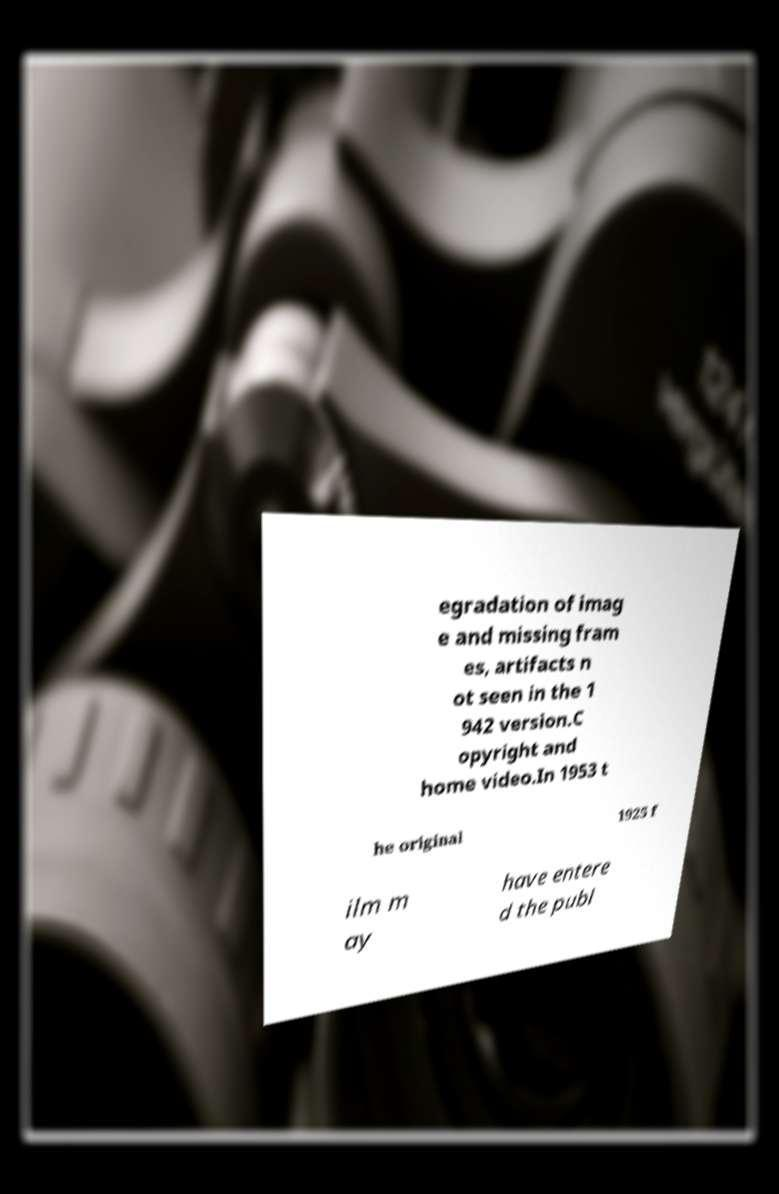There's text embedded in this image that I need extracted. Can you transcribe it verbatim? egradation of imag e and missing fram es, artifacts n ot seen in the 1 942 version.C opyright and home video.In 1953 t he original 1925 f ilm m ay have entere d the publ 